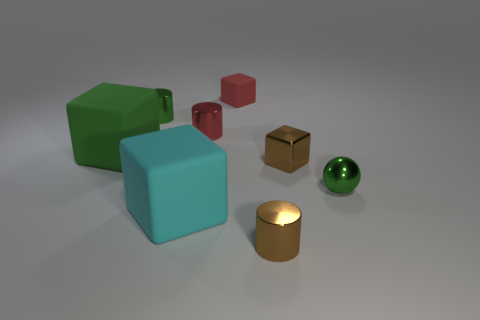Are there any other things that have the same color as the small shiny ball?
Offer a very short reply. Yes. What number of objects are cyan objects that are in front of the red matte block or small metal objects left of the large cyan block?
Provide a succinct answer. 2. The object that is both on the right side of the red metal cylinder and in front of the green sphere has what shape?
Your answer should be compact. Cylinder. There is a small red object to the left of the red matte object; what number of green shiny objects are to the left of it?
Provide a succinct answer. 1. Is there any other thing that is made of the same material as the ball?
Your response must be concise. Yes. What number of things are brown shiny objects that are on the left side of the tiny metal cube or balls?
Your response must be concise. 2. There is a cylinder left of the small red cylinder; how big is it?
Provide a succinct answer. Small. What is the small brown block made of?
Make the answer very short. Metal. There is a green object on the right side of the tiny brown metal object in front of the small brown shiny block; what is its shape?
Your answer should be very brief. Sphere. How many other things are there of the same shape as the small red rubber thing?
Offer a very short reply. 3. 